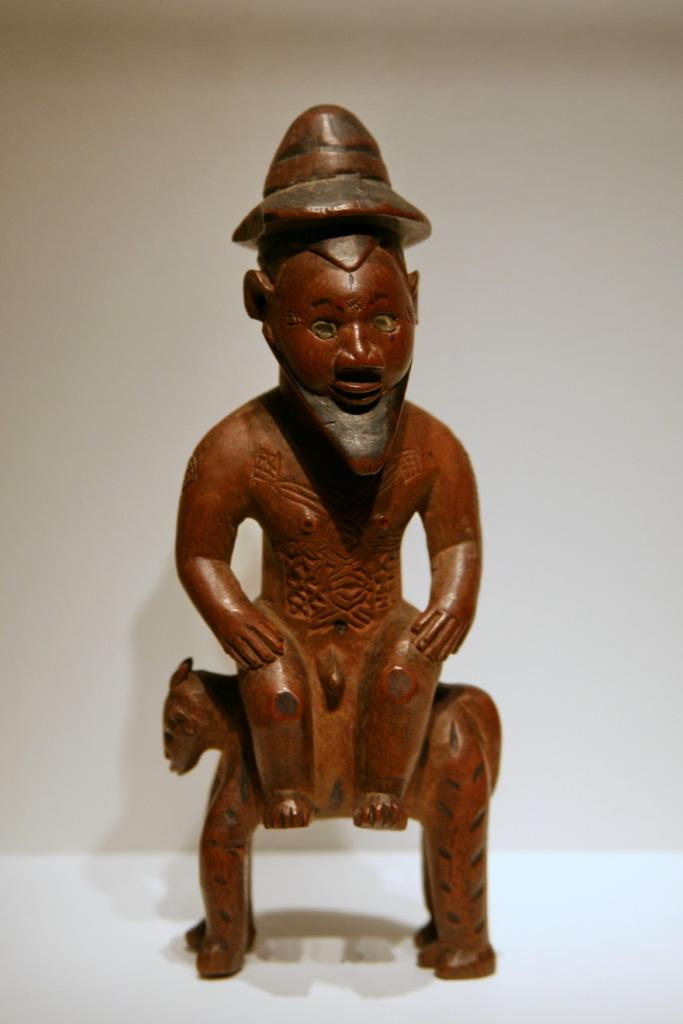What is the main subject in the center of the image? There is a toy sculpture in the center of the image. What can be seen in the background of the image? There is a wall in the background of the image. What type of tin can be seen in the image? There is no tin present in the image. What kind of teeth can be seen on the toy sculpture in the image? The toy sculpture does not have teeth, as it is not a living creature. 